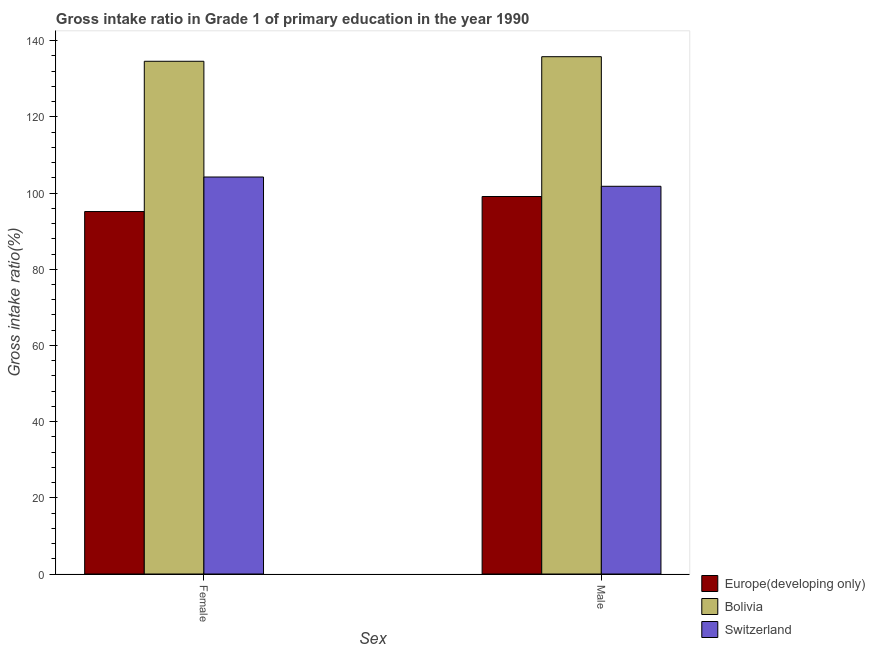How many bars are there on the 2nd tick from the left?
Offer a terse response. 3. What is the gross intake ratio(female) in Europe(developing only)?
Offer a terse response. 95.16. Across all countries, what is the maximum gross intake ratio(female)?
Your answer should be compact. 134.61. Across all countries, what is the minimum gross intake ratio(male)?
Offer a terse response. 99.1. In which country was the gross intake ratio(female) minimum?
Your answer should be compact. Europe(developing only). What is the total gross intake ratio(female) in the graph?
Keep it short and to the point. 334. What is the difference between the gross intake ratio(male) in Bolivia and that in Switzerland?
Provide a succinct answer. 34.02. What is the difference between the gross intake ratio(male) in Europe(developing only) and the gross intake ratio(female) in Bolivia?
Provide a succinct answer. -35.51. What is the average gross intake ratio(male) per country?
Your answer should be compact. 112.24. What is the difference between the gross intake ratio(female) and gross intake ratio(male) in Europe(developing only)?
Your answer should be very brief. -3.95. In how many countries, is the gross intake ratio(female) greater than 24 %?
Keep it short and to the point. 3. What is the ratio of the gross intake ratio(male) in Europe(developing only) to that in Switzerland?
Your response must be concise. 0.97. In how many countries, is the gross intake ratio(male) greater than the average gross intake ratio(male) taken over all countries?
Your response must be concise. 1. What does the 3rd bar from the left in Female represents?
Make the answer very short. Switzerland. What does the 3rd bar from the right in Female represents?
Ensure brevity in your answer.  Europe(developing only). How many bars are there?
Give a very brief answer. 6. How many countries are there in the graph?
Offer a terse response. 3. What is the difference between two consecutive major ticks on the Y-axis?
Your response must be concise. 20. Does the graph contain any zero values?
Your response must be concise. No. Does the graph contain grids?
Offer a very short reply. No. How many legend labels are there?
Your response must be concise. 3. How are the legend labels stacked?
Provide a short and direct response. Vertical. What is the title of the graph?
Offer a terse response. Gross intake ratio in Grade 1 of primary education in the year 1990. What is the label or title of the X-axis?
Keep it short and to the point. Sex. What is the label or title of the Y-axis?
Offer a terse response. Gross intake ratio(%). What is the Gross intake ratio(%) of Europe(developing only) in Female?
Your answer should be very brief. 95.16. What is the Gross intake ratio(%) in Bolivia in Female?
Ensure brevity in your answer.  134.61. What is the Gross intake ratio(%) in Switzerland in Female?
Offer a very short reply. 104.23. What is the Gross intake ratio(%) in Europe(developing only) in Male?
Provide a succinct answer. 99.1. What is the Gross intake ratio(%) of Bolivia in Male?
Provide a short and direct response. 135.81. What is the Gross intake ratio(%) in Switzerland in Male?
Keep it short and to the point. 101.79. Across all Sex, what is the maximum Gross intake ratio(%) of Europe(developing only)?
Offer a very short reply. 99.1. Across all Sex, what is the maximum Gross intake ratio(%) in Bolivia?
Offer a terse response. 135.81. Across all Sex, what is the maximum Gross intake ratio(%) of Switzerland?
Your answer should be compact. 104.23. Across all Sex, what is the minimum Gross intake ratio(%) in Europe(developing only)?
Ensure brevity in your answer.  95.16. Across all Sex, what is the minimum Gross intake ratio(%) of Bolivia?
Your answer should be compact. 134.61. Across all Sex, what is the minimum Gross intake ratio(%) in Switzerland?
Provide a short and direct response. 101.79. What is the total Gross intake ratio(%) in Europe(developing only) in the graph?
Your response must be concise. 194.26. What is the total Gross intake ratio(%) of Bolivia in the graph?
Your answer should be very brief. 270.42. What is the total Gross intake ratio(%) of Switzerland in the graph?
Offer a very short reply. 206.01. What is the difference between the Gross intake ratio(%) of Europe(developing only) in Female and that in Male?
Keep it short and to the point. -3.95. What is the difference between the Gross intake ratio(%) in Bolivia in Female and that in Male?
Keep it short and to the point. -1.2. What is the difference between the Gross intake ratio(%) in Switzerland in Female and that in Male?
Provide a succinct answer. 2.44. What is the difference between the Gross intake ratio(%) of Europe(developing only) in Female and the Gross intake ratio(%) of Bolivia in Male?
Offer a terse response. -40.65. What is the difference between the Gross intake ratio(%) of Europe(developing only) in Female and the Gross intake ratio(%) of Switzerland in Male?
Your response must be concise. -6.63. What is the difference between the Gross intake ratio(%) in Bolivia in Female and the Gross intake ratio(%) in Switzerland in Male?
Ensure brevity in your answer.  32.82. What is the average Gross intake ratio(%) in Europe(developing only) per Sex?
Keep it short and to the point. 97.13. What is the average Gross intake ratio(%) of Bolivia per Sex?
Your response must be concise. 135.21. What is the average Gross intake ratio(%) of Switzerland per Sex?
Your answer should be compact. 103.01. What is the difference between the Gross intake ratio(%) in Europe(developing only) and Gross intake ratio(%) in Bolivia in Female?
Provide a succinct answer. -39.45. What is the difference between the Gross intake ratio(%) of Europe(developing only) and Gross intake ratio(%) of Switzerland in Female?
Offer a very short reply. -9.07. What is the difference between the Gross intake ratio(%) in Bolivia and Gross intake ratio(%) in Switzerland in Female?
Provide a short and direct response. 30.39. What is the difference between the Gross intake ratio(%) of Europe(developing only) and Gross intake ratio(%) of Bolivia in Male?
Make the answer very short. -36.71. What is the difference between the Gross intake ratio(%) of Europe(developing only) and Gross intake ratio(%) of Switzerland in Male?
Give a very brief answer. -2.68. What is the difference between the Gross intake ratio(%) of Bolivia and Gross intake ratio(%) of Switzerland in Male?
Give a very brief answer. 34.02. What is the ratio of the Gross intake ratio(%) in Europe(developing only) in Female to that in Male?
Provide a succinct answer. 0.96. What is the ratio of the Gross intake ratio(%) in Switzerland in Female to that in Male?
Provide a short and direct response. 1.02. What is the difference between the highest and the second highest Gross intake ratio(%) of Europe(developing only)?
Keep it short and to the point. 3.95. What is the difference between the highest and the second highest Gross intake ratio(%) in Bolivia?
Offer a terse response. 1.2. What is the difference between the highest and the second highest Gross intake ratio(%) of Switzerland?
Provide a short and direct response. 2.44. What is the difference between the highest and the lowest Gross intake ratio(%) in Europe(developing only)?
Keep it short and to the point. 3.95. What is the difference between the highest and the lowest Gross intake ratio(%) in Bolivia?
Your answer should be very brief. 1.2. What is the difference between the highest and the lowest Gross intake ratio(%) of Switzerland?
Give a very brief answer. 2.44. 